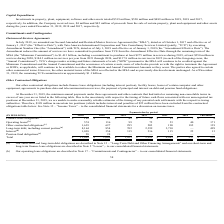According to Nielsen Nv's financial document, What do the other contractual obligations include? finance lease obligations (including interest portion), facility leases, leases of certain computer and other equipment, agreements to purchase data and telecommunication services, the payment of principal and interest on debt and pension fund obligations. The document states: "Our other contractual obligations include finance lease obligations (including interest portion), facility leases, leases of certain computer and othe..." Also, What is the total amount of finance lease obligations? According to the financial document, $162 (in millions). The relevant text states: "Finance lease obligations (a) $ 162 $ 61 $ 42 $ 29 $ 15 $ 7 $ 8..." Also, What is the total amount of payments due? According to the financial document, 11,605 (in millions). The relevant text states: "Total $ 11,605 $ 2,060 $ 1,453 $ 2,922 $ 4,083 $ 257 $ 830..." Also, can you calculate: What is the percentage of total pension fund obligations in the total amount of payments due? Based on the calculation: 28/11,605, the result is 0.24 (percentage). This is based on the information: "Pension fund obligations (e) 28 28 — — — — — Total $ 11,605 $ 2,060 $ 1,453 $ 2,922 $ 4,083 $ 257 $ 830..." The key data points involved are: 11,605, 28. Also, can you calculate: What is the percentage constitution of amount of finance lease obligations due in 2024 among the total amount? Based on the calculation: 7/162, the result is 4.32 (percentage). This is based on the information: "520 million and $489 million in 2019, 2018 and 2017, Finance lease obligations (a) $ 162 $ 61 $ 42 $ 29 $ 15 $ 7 $ 8..." The key data points involved are: 162, 7. Also, can you calculate: What is the difference between the total payment for operating leases and finance lease obligations? Based on the calculation: 574-162, the result is 412 (in millions). This is based on the information: "Finance lease obligations (a) $ 162 $ 61 $ 42 $ 29 $ 15 $ 7 $ 8 Operating leases (b) 574 136 99 75 53 40 171..." The key data points involved are: 162, 574. 